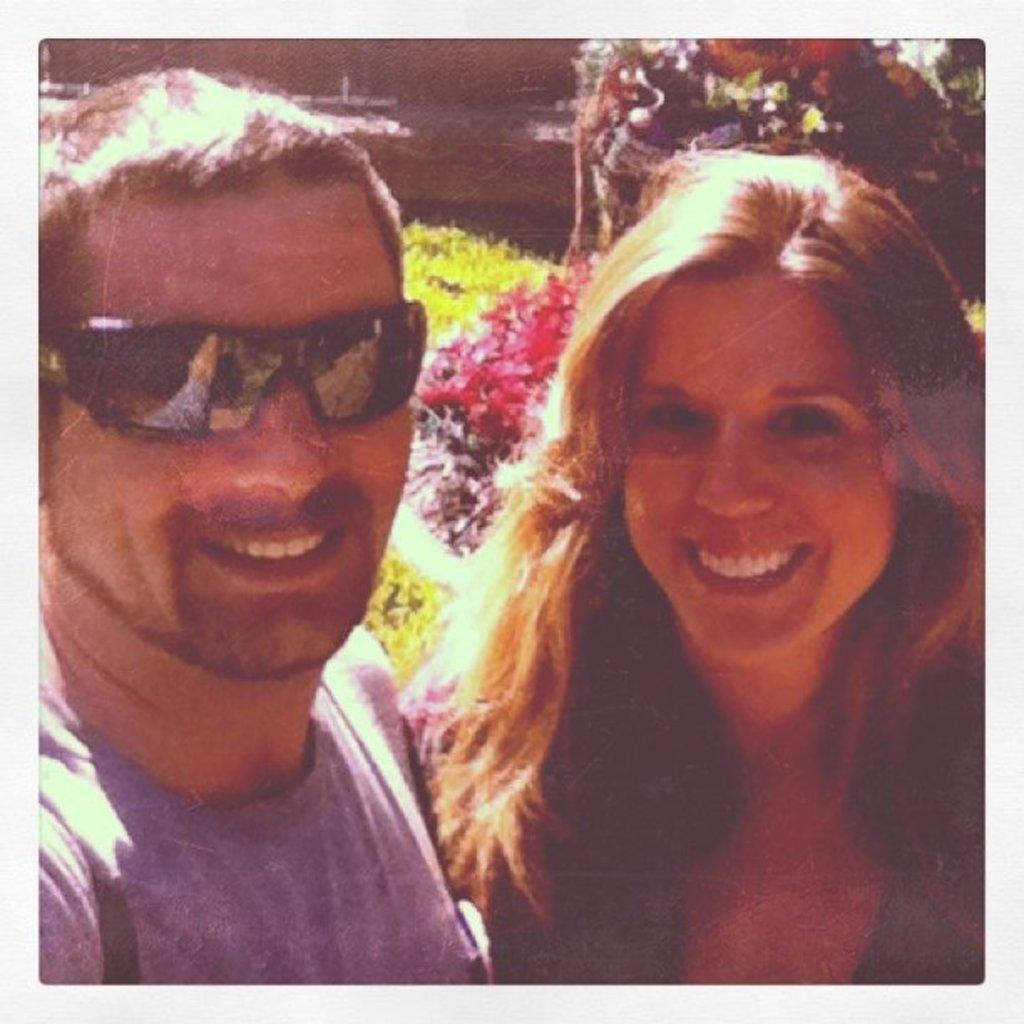What is the man on the left side of the image wearing? The man on the left side of the image is wearing goggles. What is the woman on the right side of the image doing? The woman on the right side of the image is smiling. What can be seen in the background of the image? There are plants in the background of the image. What is the weather like in the image? It is a sunny day in the image. How many eggs are visible in the image? There are no eggs present in the image. What type of ring is the woman wearing on her finger? There is no ring visible on the woman's finger in the image. 